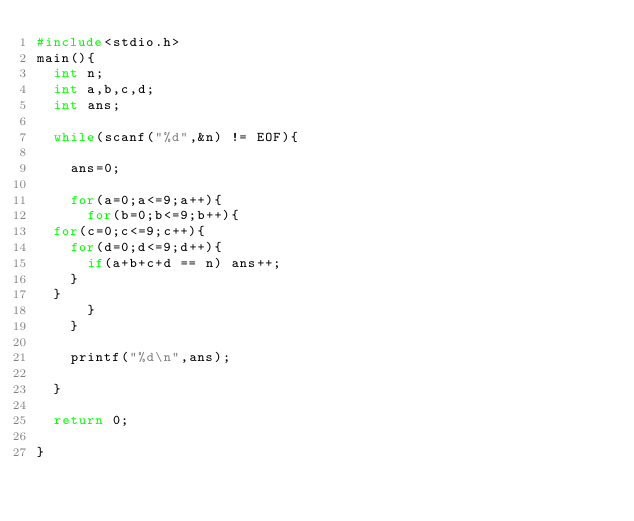Convert code to text. <code><loc_0><loc_0><loc_500><loc_500><_C_>#include<stdio.h>
main(){
  int n;
  int a,b,c,d;
  int ans;

  while(scanf("%d",&n) != EOF){

    ans=0;

    for(a=0;a<=9;a++){
      for(b=0;b<=9;b++){
	for(c=0;c<=9;c++){
	  for(d=0;d<=9;d++){
	    if(a+b+c+d == n) ans++;
	  }
	}
      }
    }

    printf("%d\n",ans);

  }

  return 0;

}</code> 